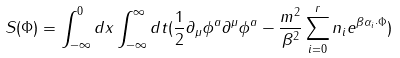Convert formula to latex. <formula><loc_0><loc_0><loc_500><loc_500>S ( \Phi ) = \int _ { - \infty } ^ { 0 } d x \int _ { - \infty } ^ { \infty } d t ( \frac { 1 } { 2 } \partial _ { \mu } \phi ^ { a } \partial ^ { \mu } \phi ^ { a } - \frac { m ^ { 2 } } { \beta ^ { 2 } } \sum _ { i = 0 } ^ { r } n _ { i } e ^ { \beta \alpha _ { i } \cdot \Phi } )</formula> 